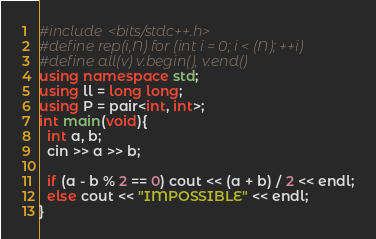<code> <loc_0><loc_0><loc_500><loc_500><_C++_>#include <bits/stdc++.h>
#define rep(i,N) for (int i = 0; i < (N); ++i)
#define all(v) v.begin(), v.end()
using namespace std;
using ll = long long;
using P = pair<int, int>;
int main(void){
  int a, b;
  cin >> a >> b;

  if (a - b % 2 == 0) cout << (a + b) / 2 << endl;
  else cout << "IMPOSSIBLE" << endl;
}
</code> 